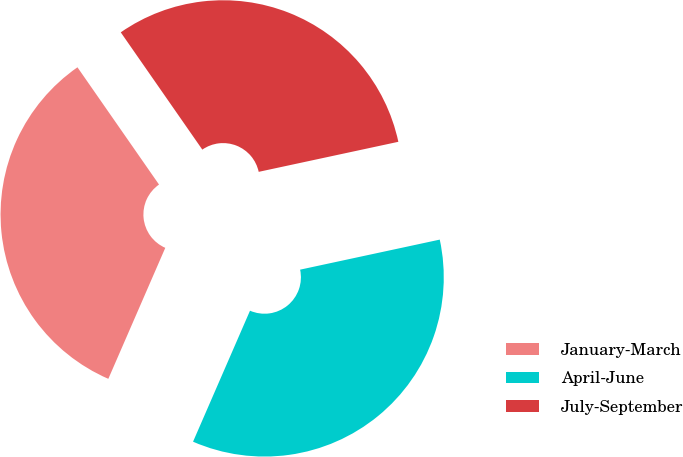Convert chart to OTSL. <chart><loc_0><loc_0><loc_500><loc_500><pie_chart><fcel>January-March<fcel>April-June<fcel>July-September<nl><fcel>33.8%<fcel>34.9%<fcel>31.3%<nl></chart> 